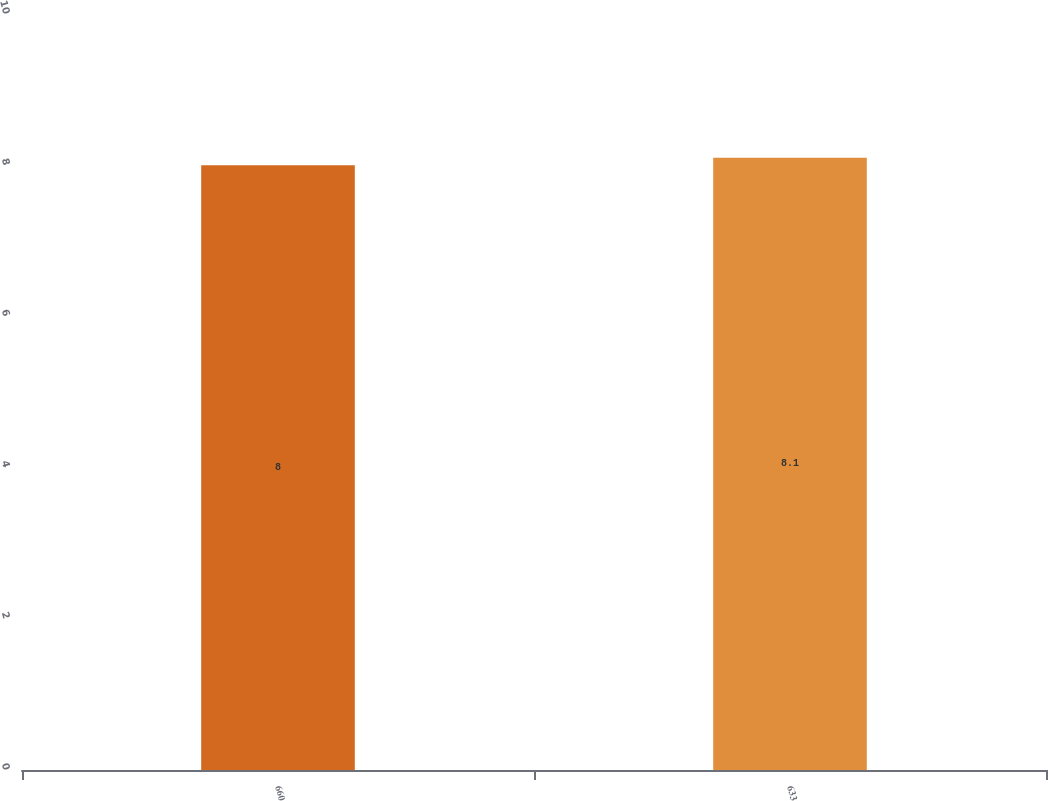<chart> <loc_0><loc_0><loc_500><loc_500><bar_chart><fcel>660<fcel>633<nl><fcel>8<fcel>8.1<nl></chart> 